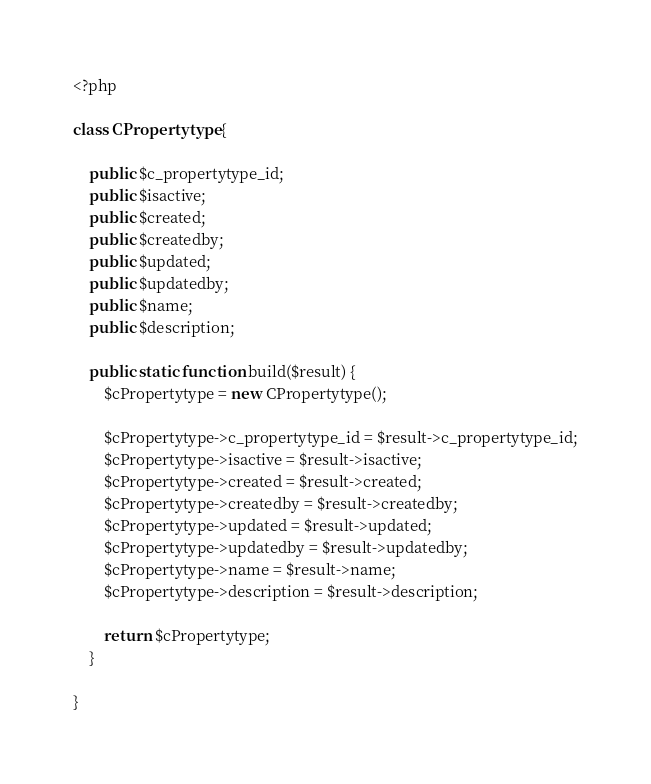<code> <loc_0><loc_0><loc_500><loc_500><_PHP_><?php

class CPropertytype {

    public $c_propertytype_id;
    public $isactive;
    public $created;
    public $createdby;
    public $updated;
    public $updatedby;
    public $name;
    public $description;

    public static function build($result) {
        $cPropertytype = new CPropertytype();

        $cPropertytype->c_propertytype_id = $result->c_propertytype_id;
        $cPropertytype->isactive = $result->isactive;
        $cPropertytype->created = $result->created;
        $cPropertytype->createdby = $result->createdby;
        $cPropertytype->updated = $result->updated;
        $cPropertytype->updatedby = $result->updatedby;
        $cPropertytype->name = $result->name;
        $cPropertytype->description = $result->description;

        return $cPropertytype;
    }

}
</code> 